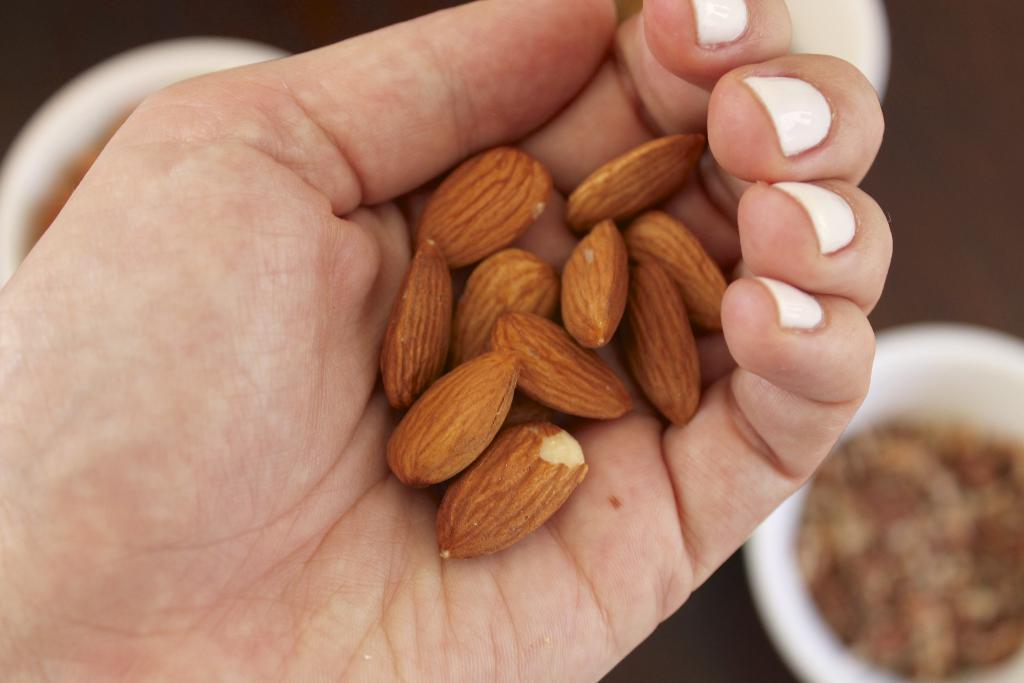Can you describe this image briefly? This picture shows a human hand holding a bunch of nuts and we see some food in the couple of bowls on the table. 